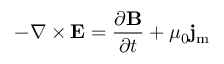Convert formula to latex. <formula><loc_0><loc_0><loc_500><loc_500>- \nabla \times E = { \frac { \partial B } { \partial t } } + \mu _ { 0 } j _ { m }</formula> 